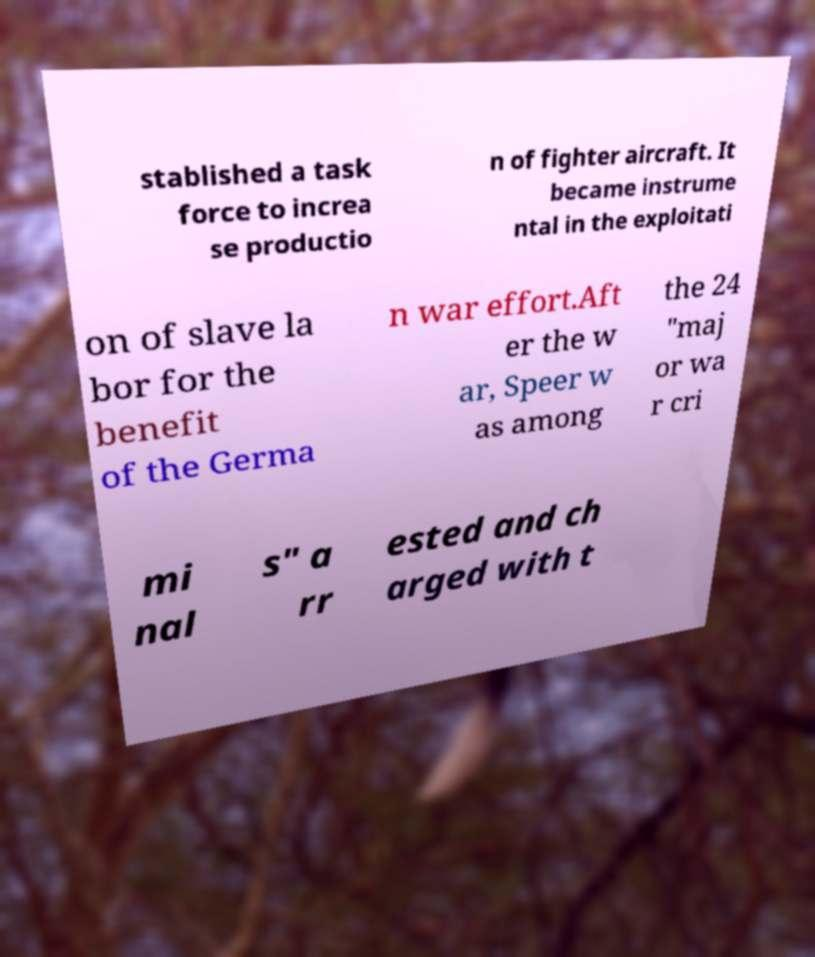I need the written content from this picture converted into text. Can you do that? stablished a task force to increa se productio n of fighter aircraft. It became instrume ntal in the exploitati on of slave la bor for the benefit of the Germa n war effort.Aft er the w ar, Speer w as among the 24 "maj or wa r cri mi nal s" a rr ested and ch arged with t 